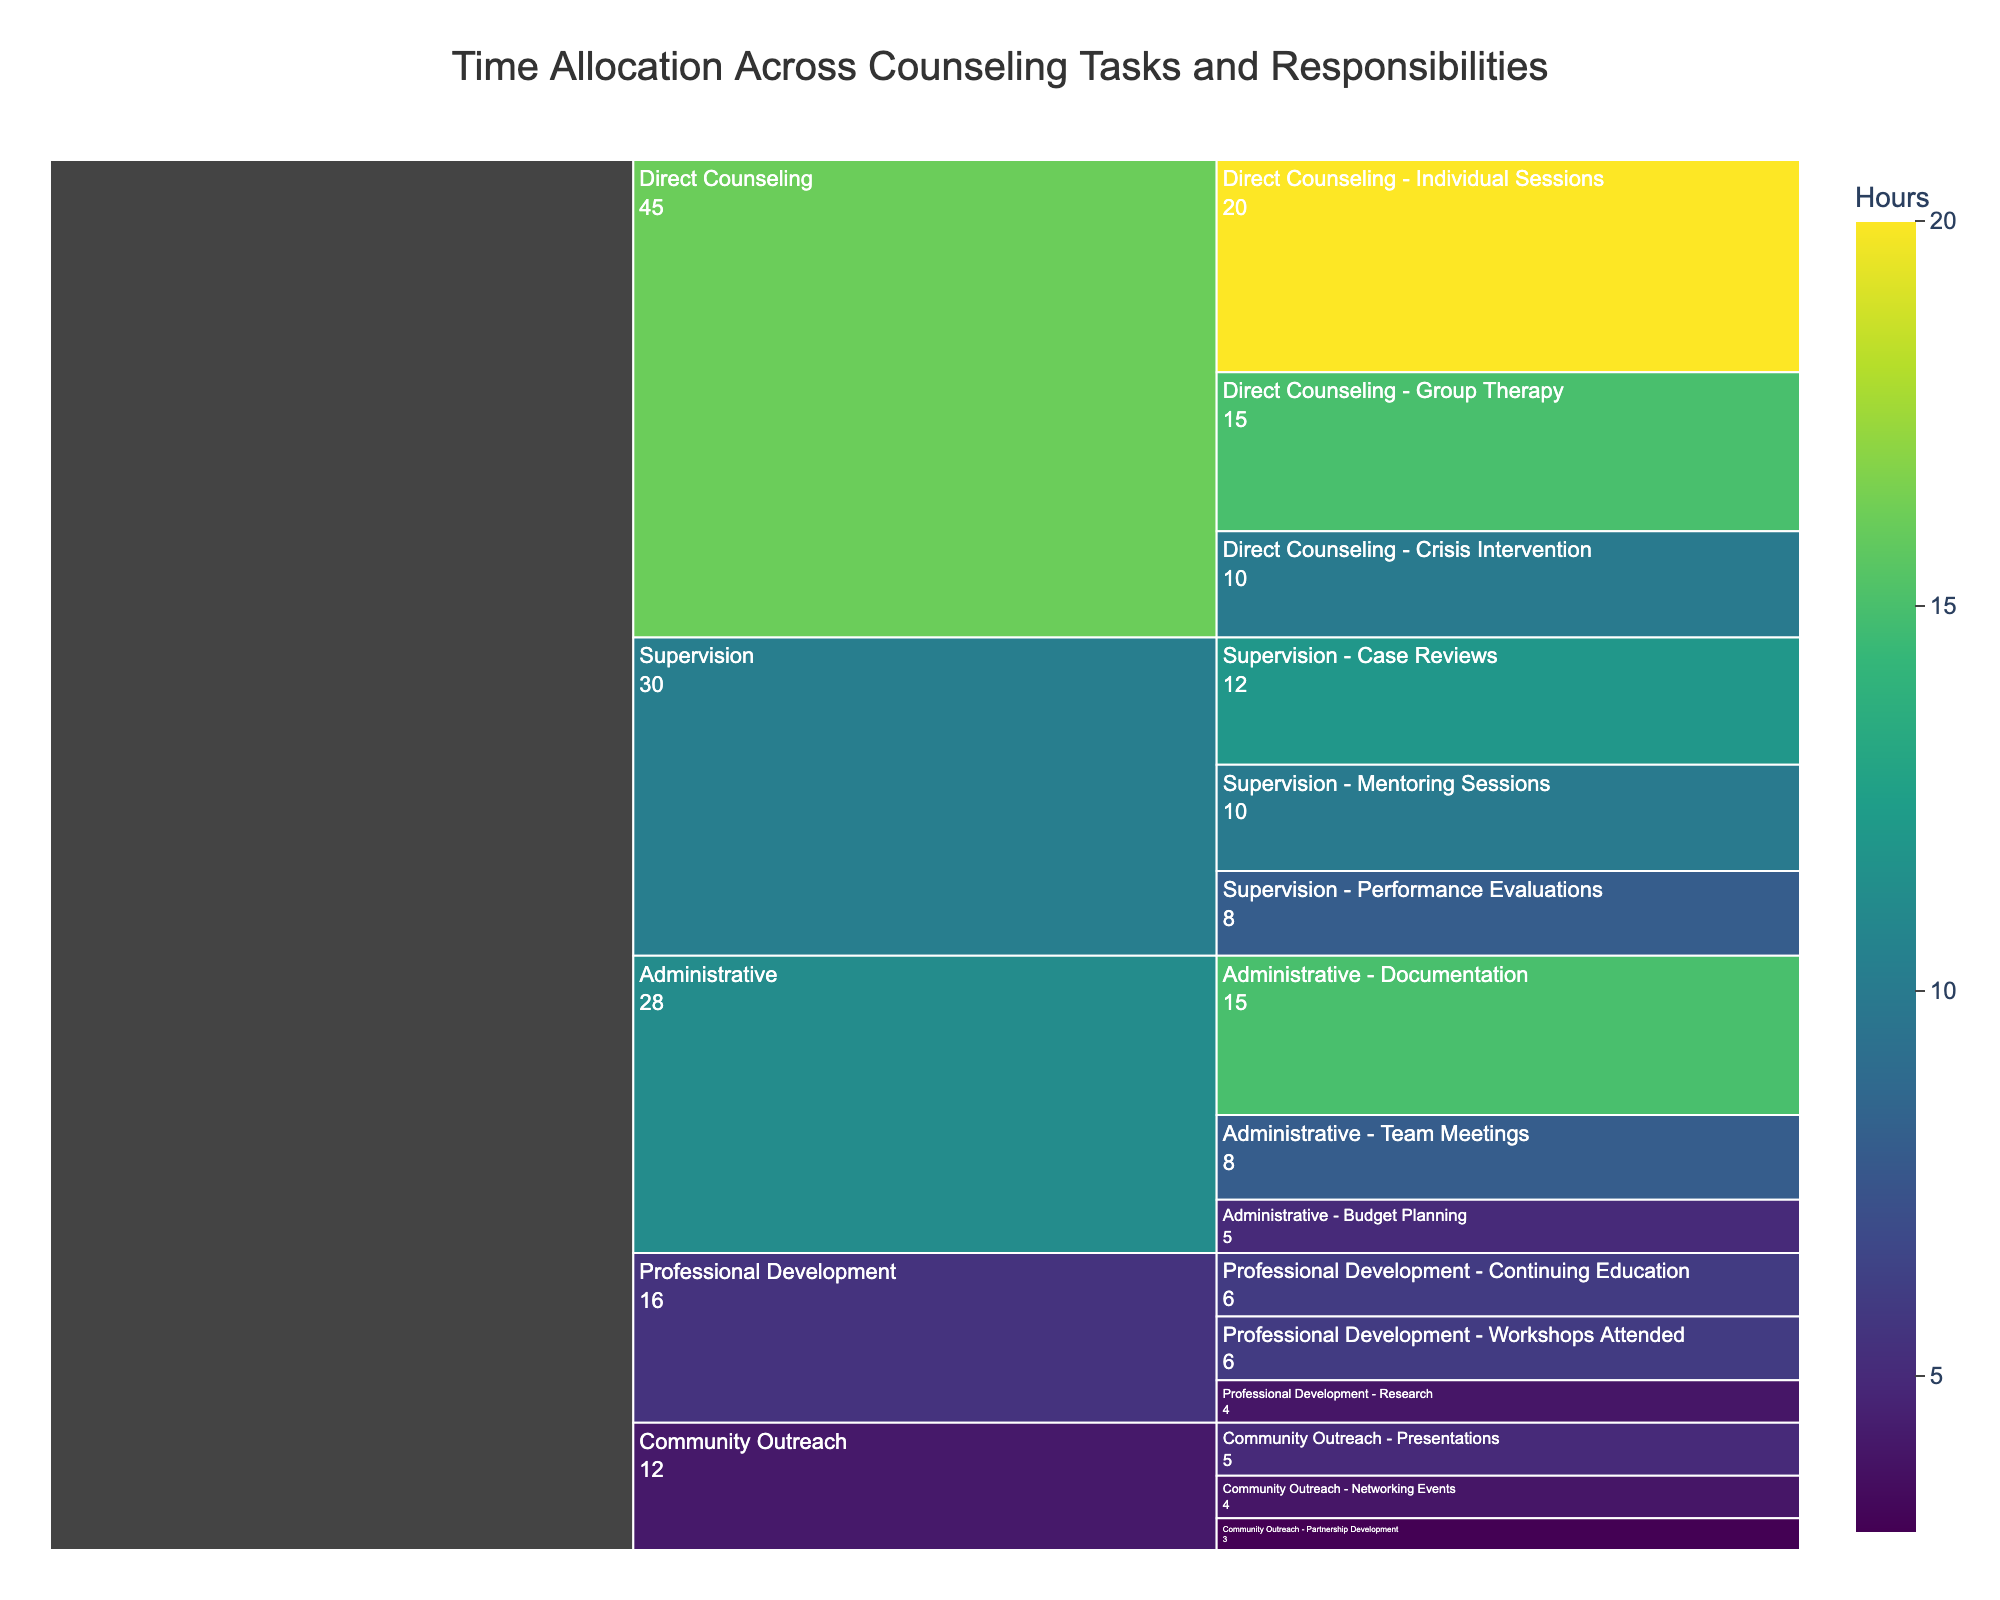What is the total time allocated for Direct Counseling? To find the total time allocated for Direct Counseling, add the time allocated to each subtask: Individual Sessions (20 hours), Group Therapy (15 hours), Crisis Intervention (10 hours). 20 + 15 + 10 = 45 hours
Answer: 45 hours Which task has the highest time allocation? By comparing the highest values among tasks, Direct Counseling has the highest total time allocation (45 hours, summing up its subtasks) compared to Supervision (30 hours), Administrative (28 hours), Professional Development (16 hours), and Community Outreach (12 hours).
Answer: Direct Counseling How much time is spent on Documentation compared to Budget Planning? According to the chart, the time allocation for Documentation is 15 hours and for Budget Planning is 5 hours. 15 - 5 = 10 hours difference.
Answer: 10 hours more Which subtask under Supervision has the highest time allocation? Under Supervision, compare the allocated times: Case Reviews (12 hours), Performance Evaluations (8 hours), and Mentoring Sessions (10 hours). Case Reviews has the highest allocation.
Answer: Case Reviews How much is the total time allocation for Administrative tasks? Sum the time allocation of all Administrative subtasks: Documentation (15 hours), Team Meetings (8 hours), Budget Planning (5 hours). 15 + 8 + 5 = 28 hours
Answer: 28 hours What is the time allocation difference between Group Therapy and Individual Sessions? Group Therapy is allocated 15 hours and Individual Sessions are allocated 20 hours. Therefore, the difference is 20 - 15 = 5 hours.
Answer: 5 hours Which subtask in Professional Development uses the least amount of time? Compare the allocated times for the subtasks: Workshops Attended (6 hours), Research (4 hours), Continuing Education (6 hours). Research has the least time allocation.
Answer: Research Among Community Outreach tasks, how much time is devoted to Presentations and Networking Events combined? Sum the time allocated for Presentations (5 hours) and Networking Events (4 hours). 5 + 4 = 9 hours
Answer: 9 hours What is the title of the chart? The title is usually displayed at the top of the figure. The given information specifies the title as "Time Allocation Across Counseling Tasks and Responsibilities".
Answer: Time Allocation Across Counseling Tasks and Responsibilities How does the color represent the data in this icicle chart? In the icicle chart, colors are used to represent the amount of time, with the Viridis color scale ranging from lighter to darker shades corresponding to increasing time allocation.
Answer: Color represents time allocation with the Viridis color scale 